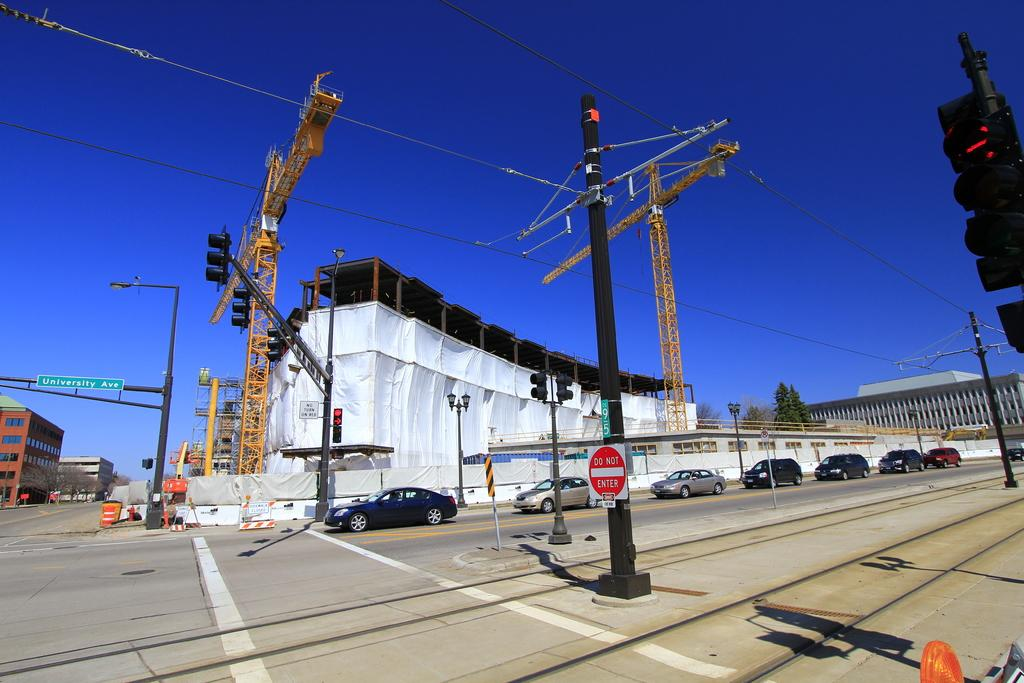<image>
Offer a succinct explanation of the picture presented. A do not enter sign is posted by a construction area with tall cranes rising into the air. 